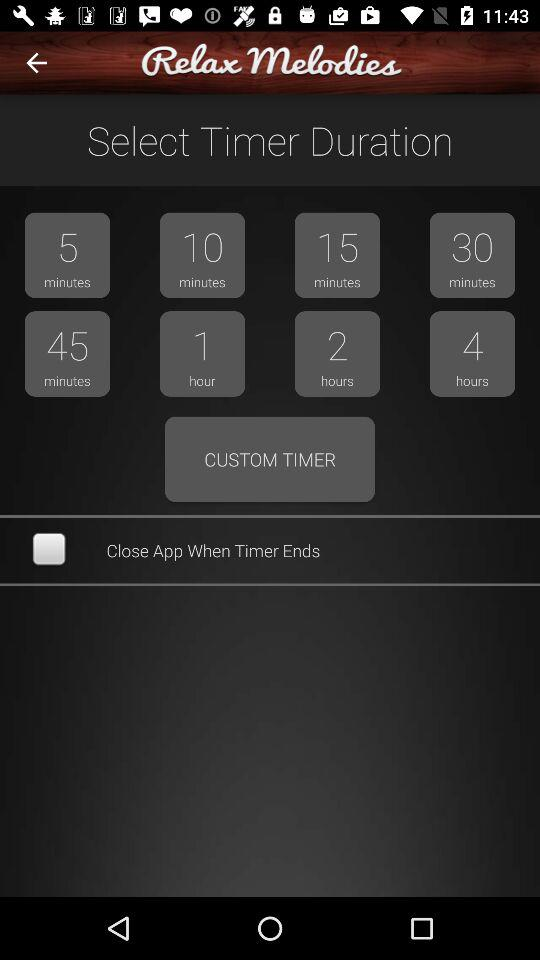Is "Close App When Timer Ends" checked or not? "Close App When Timer Ends" is not checked. 